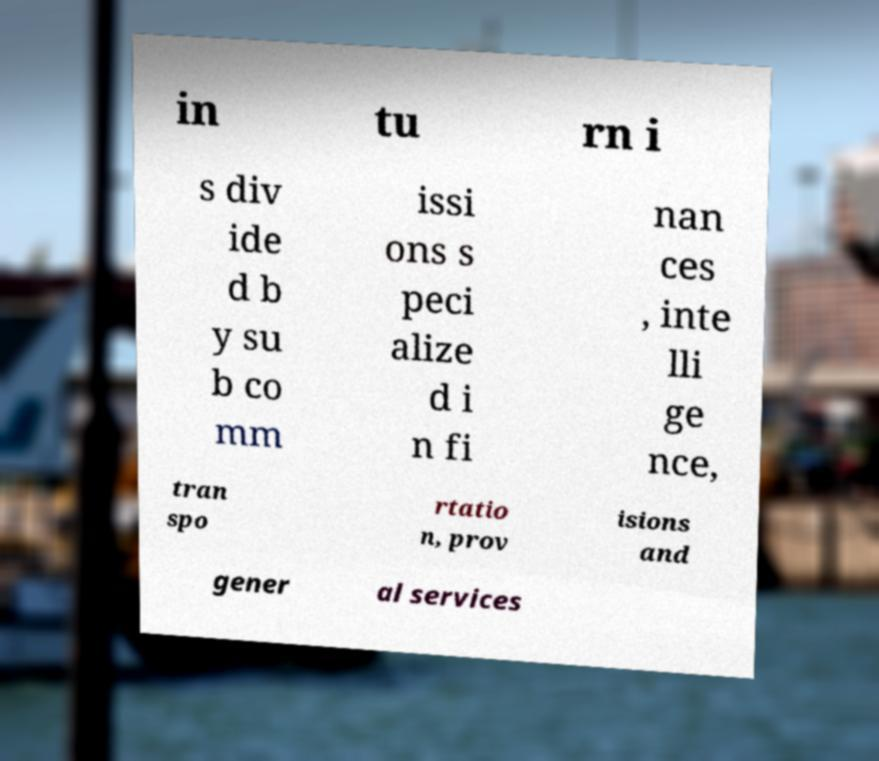Can you read and provide the text displayed in the image?This photo seems to have some interesting text. Can you extract and type it out for me? in tu rn i s div ide d b y su b co mm issi ons s peci alize d i n fi nan ces , inte lli ge nce, tran spo rtatio n, prov isions and gener al services 